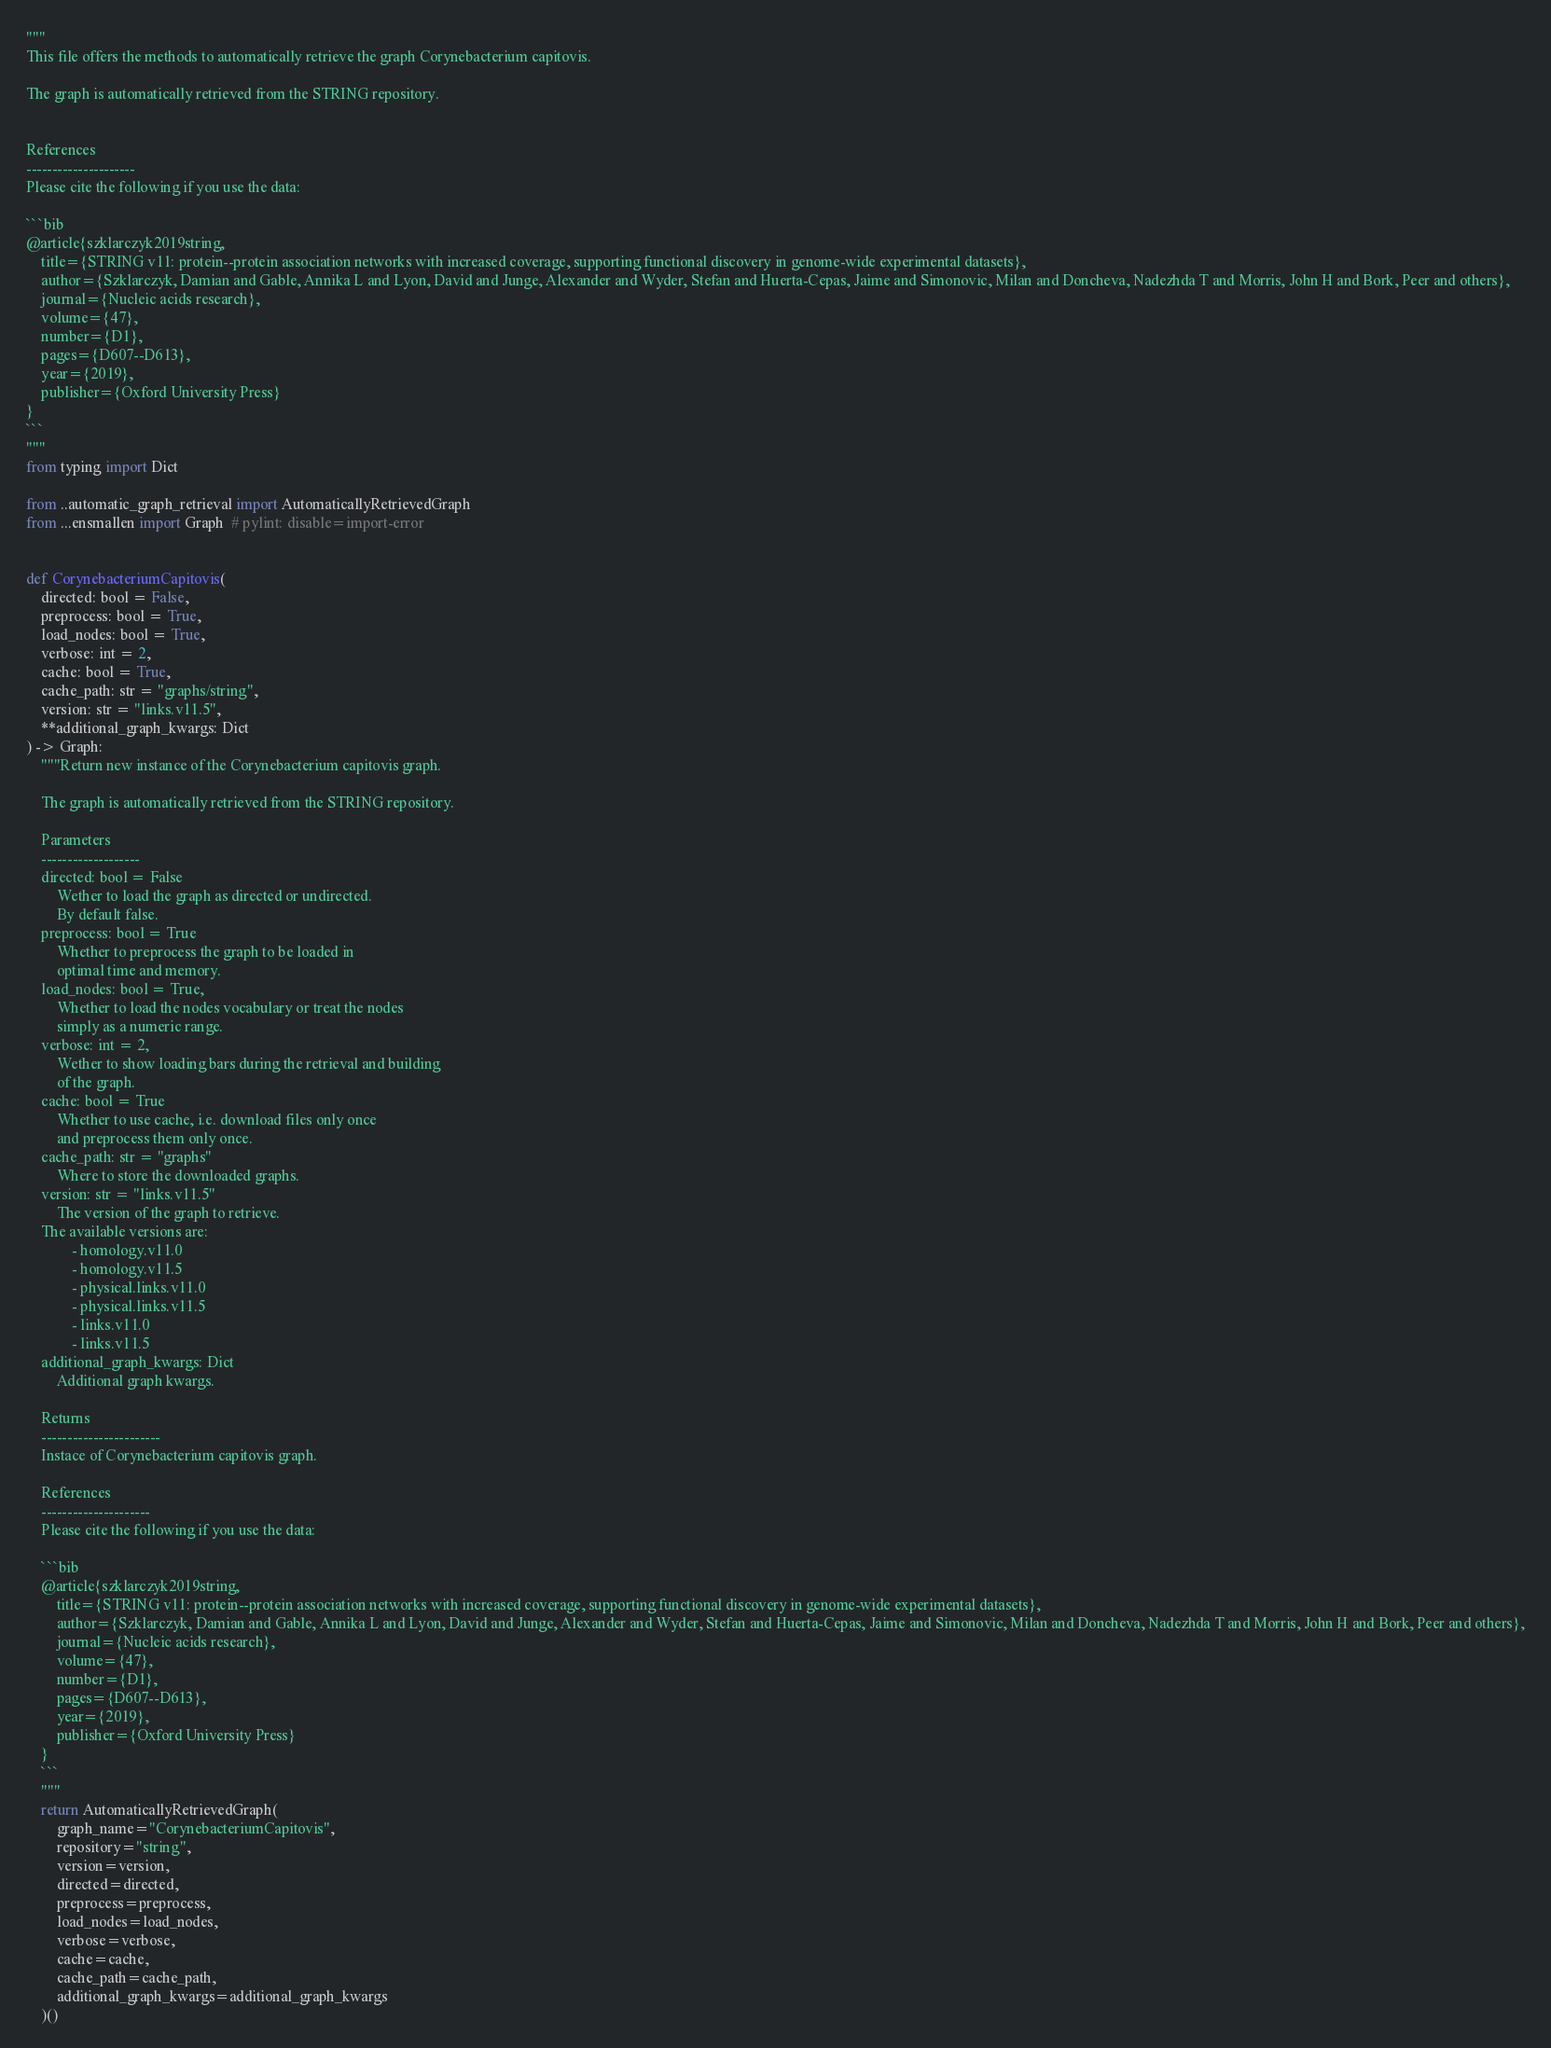Convert code to text. <code><loc_0><loc_0><loc_500><loc_500><_Python_>"""
This file offers the methods to automatically retrieve the graph Corynebacterium capitovis.

The graph is automatically retrieved from the STRING repository. 


References
---------------------
Please cite the following if you use the data:

```bib
@article{szklarczyk2019string,
    title={STRING v11: protein--protein association networks with increased coverage, supporting functional discovery in genome-wide experimental datasets},
    author={Szklarczyk, Damian and Gable, Annika L and Lyon, David and Junge, Alexander and Wyder, Stefan and Huerta-Cepas, Jaime and Simonovic, Milan and Doncheva, Nadezhda T and Morris, John H and Bork, Peer and others},
    journal={Nucleic acids research},
    volume={47},
    number={D1},
    pages={D607--D613},
    year={2019},
    publisher={Oxford University Press}
}
```
"""
from typing import Dict

from ..automatic_graph_retrieval import AutomaticallyRetrievedGraph
from ...ensmallen import Graph  # pylint: disable=import-error


def CorynebacteriumCapitovis(
    directed: bool = False,
    preprocess: bool = True,
    load_nodes: bool = True,
    verbose: int = 2,
    cache: bool = True,
    cache_path: str = "graphs/string",
    version: str = "links.v11.5",
    **additional_graph_kwargs: Dict
) -> Graph:
    """Return new instance of the Corynebacterium capitovis graph.

    The graph is automatically retrieved from the STRING repository.	

    Parameters
    -------------------
    directed: bool = False
        Wether to load the graph as directed or undirected.
        By default false.
    preprocess: bool = True
        Whether to preprocess the graph to be loaded in 
        optimal time and memory.
    load_nodes: bool = True,
        Whether to load the nodes vocabulary or treat the nodes
        simply as a numeric range.
    verbose: int = 2,
        Wether to show loading bars during the retrieval and building
        of the graph.
    cache: bool = True
        Whether to use cache, i.e. download files only once
        and preprocess them only once.
    cache_path: str = "graphs"
        Where to store the downloaded graphs.
    version: str = "links.v11.5"
        The version of the graph to retrieve.		
	The available versions are:
			- homology.v11.0
			- homology.v11.5
			- physical.links.v11.0
			- physical.links.v11.5
			- links.v11.0
			- links.v11.5
    additional_graph_kwargs: Dict
        Additional graph kwargs.

    Returns
    -----------------------
    Instace of Corynebacterium capitovis graph.

	References
	---------------------
	Please cite the following if you use the data:
	
	```bib
	@article{szklarczyk2019string,
	    title={STRING v11: protein--protein association networks with increased coverage, supporting functional discovery in genome-wide experimental datasets},
	    author={Szklarczyk, Damian and Gable, Annika L and Lyon, David and Junge, Alexander and Wyder, Stefan and Huerta-Cepas, Jaime and Simonovic, Milan and Doncheva, Nadezhda T and Morris, John H and Bork, Peer and others},
	    journal={Nucleic acids research},
	    volume={47},
	    number={D1},
	    pages={D607--D613},
	    year={2019},
	    publisher={Oxford University Press}
	}
	```
    """
    return AutomaticallyRetrievedGraph(
        graph_name="CorynebacteriumCapitovis",
        repository="string",
        version=version,
        directed=directed,
        preprocess=preprocess,
        load_nodes=load_nodes,
        verbose=verbose,
        cache=cache,
        cache_path=cache_path,
        additional_graph_kwargs=additional_graph_kwargs
    )()
</code> 